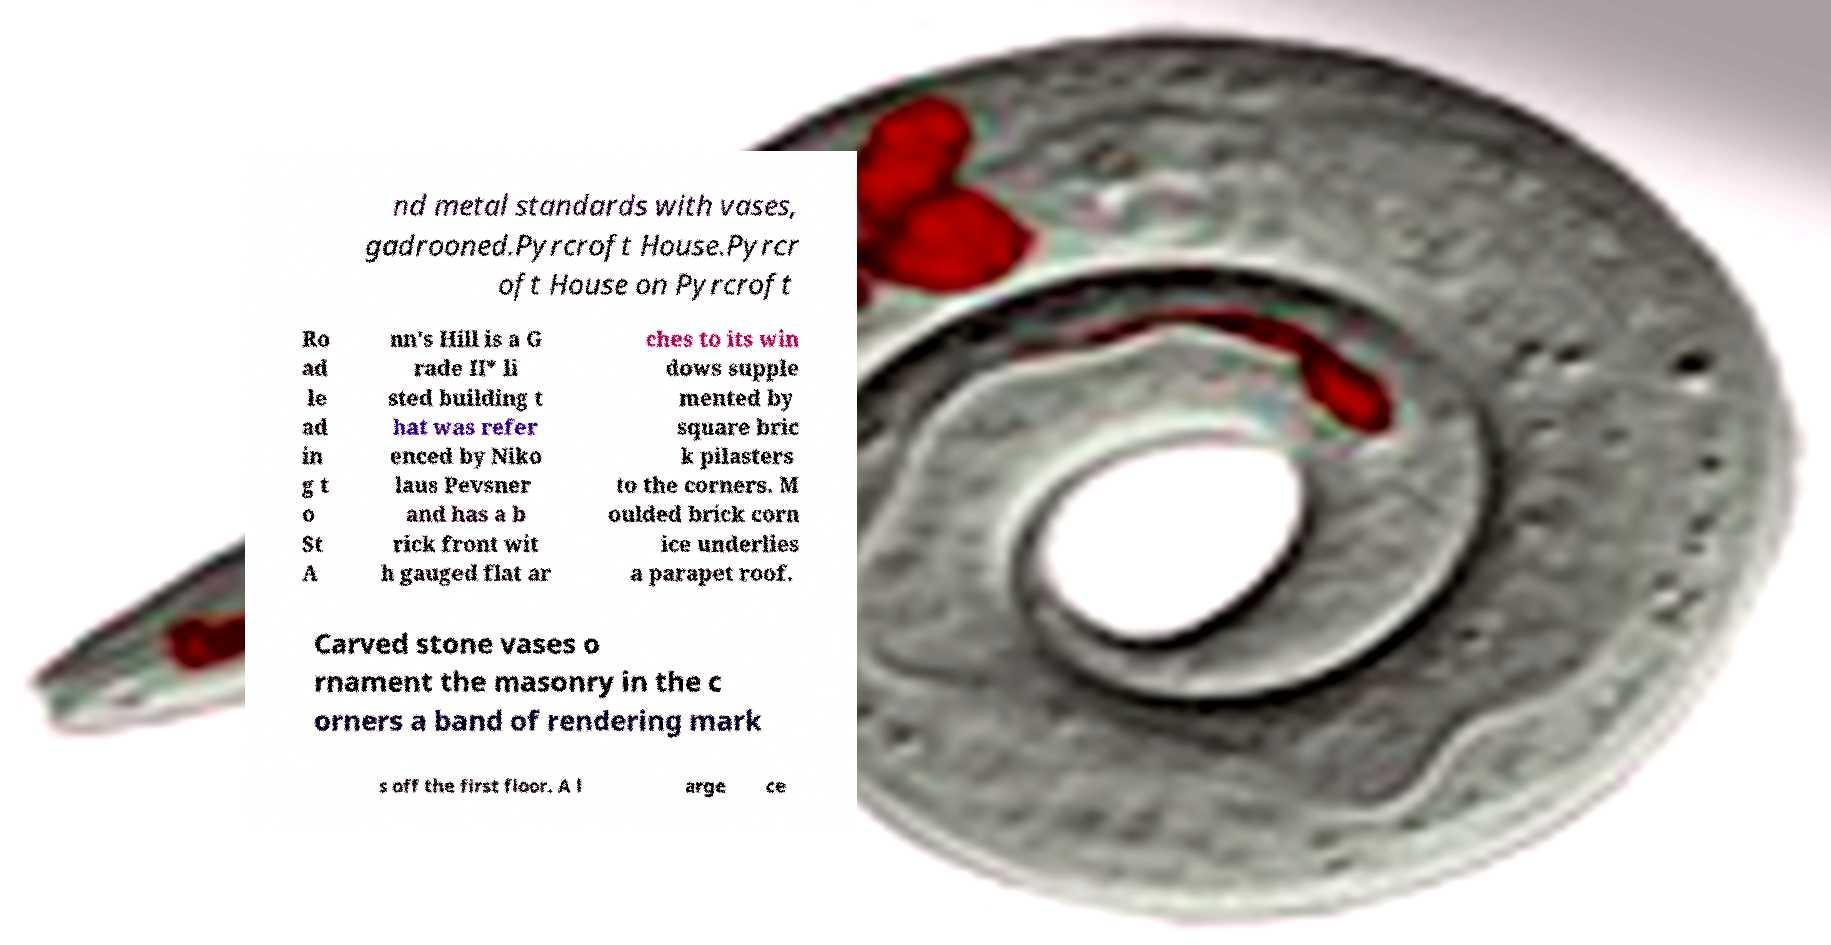Could you extract and type out the text from this image? nd metal standards with vases, gadrooned.Pyrcroft House.Pyrcr oft House on Pyrcroft Ro ad le ad in g t o St A nn's Hill is a G rade II* li sted building t hat was refer enced by Niko laus Pevsner and has a b rick front wit h gauged flat ar ches to its win dows supple mented by square bric k pilasters to the corners. M oulded brick corn ice underlies a parapet roof. Carved stone vases o rnament the masonry in the c orners a band of rendering mark s off the first floor. A l arge ce 